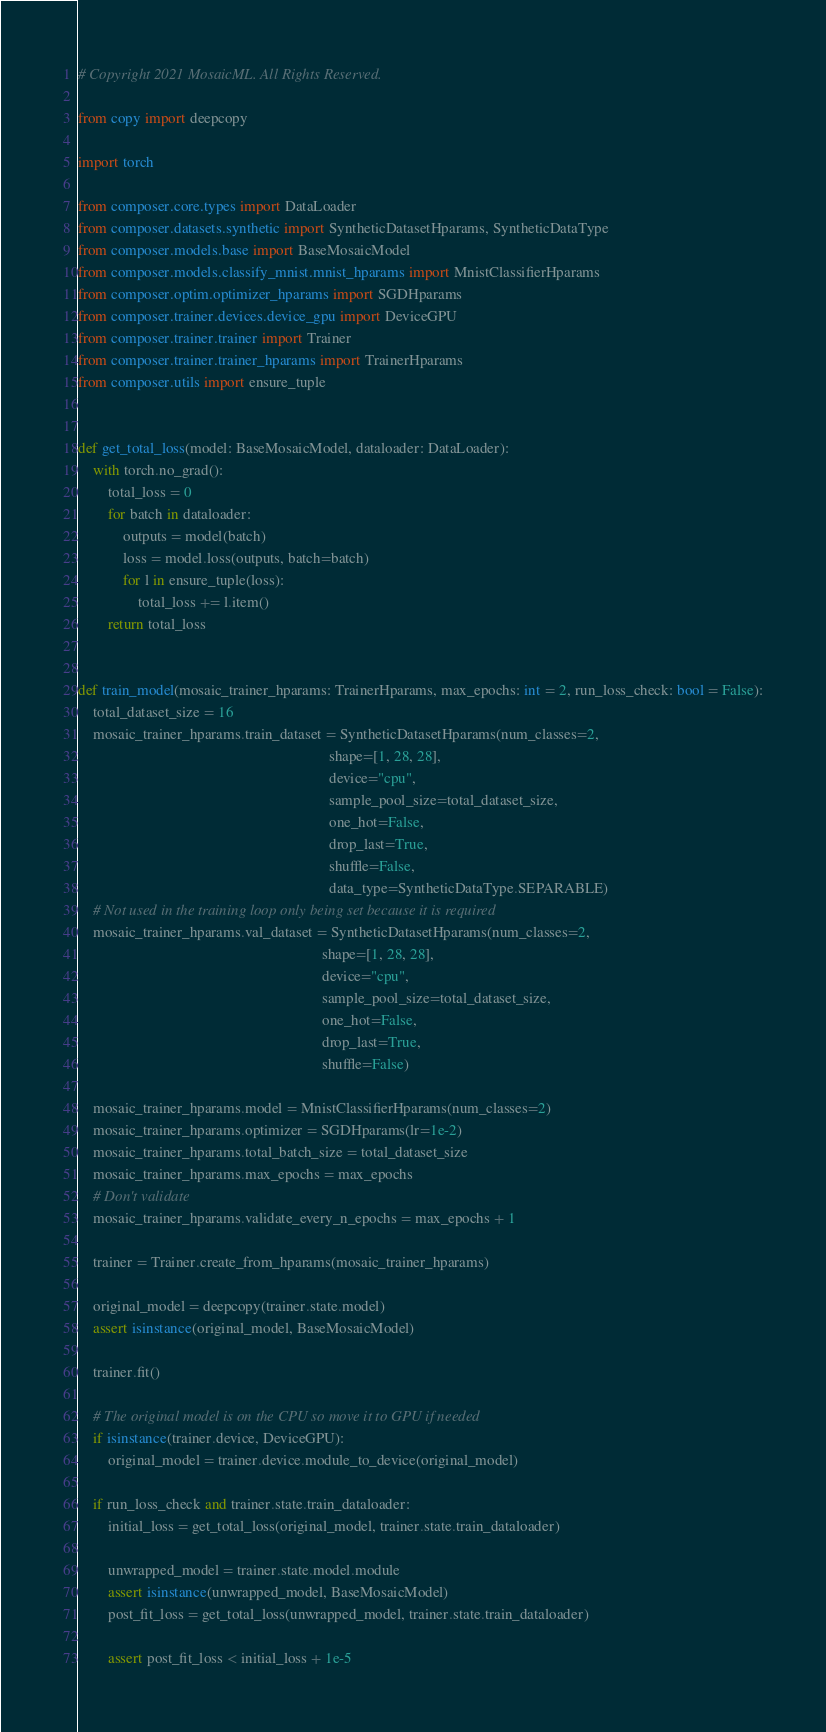<code> <loc_0><loc_0><loc_500><loc_500><_Python_># Copyright 2021 MosaicML. All Rights Reserved.

from copy import deepcopy

import torch

from composer.core.types import DataLoader
from composer.datasets.synthetic import SyntheticDatasetHparams, SyntheticDataType
from composer.models.base import BaseMosaicModel
from composer.models.classify_mnist.mnist_hparams import MnistClassifierHparams
from composer.optim.optimizer_hparams import SGDHparams
from composer.trainer.devices.device_gpu import DeviceGPU
from composer.trainer.trainer import Trainer
from composer.trainer.trainer_hparams import TrainerHparams
from composer.utils import ensure_tuple


def get_total_loss(model: BaseMosaicModel, dataloader: DataLoader):
    with torch.no_grad():
        total_loss = 0
        for batch in dataloader:
            outputs = model(batch)
            loss = model.loss(outputs, batch=batch)
            for l in ensure_tuple(loss):
                total_loss += l.item()
        return total_loss


def train_model(mosaic_trainer_hparams: TrainerHparams, max_epochs: int = 2, run_loss_check: bool = False):
    total_dataset_size = 16
    mosaic_trainer_hparams.train_dataset = SyntheticDatasetHparams(num_classes=2,
                                                                   shape=[1, 28, 28],
                                                                   device="cpu",
                                                                   sample_pool_size=total_dataset_size,
                                                                   one_hot=False,
                                                                   drop_last=True,
                                                                   shuffle=False,
                                                                   data_type=SyntheticDataType.SEPARABLE)
    # Not used in the training loop only being set because it is required
    mosaic_trainer_hparams.val_dataset = SyntheticDatasetHparams(num_classes=2,
                                                                 shape=[1, 28, 28],
                                                                 device="cpu",
                                                                 sample_pool_size=total_dataset_size,
                                                                 one_hot=False,
                                                                 drop_last=True,
                                                                 shuffle=False)

    mosaic_trainer_hparams.model = MnistClassifierHparams(num_classes=2)
    mosaic_trainer_hparams.optimizer = SGDHparams(lr=1e-2)
    mosaic_trainer_hparams.total_batch_size = total_dataset_size
    mosaic_trainer_hparams.max_epochs = max_epochs
    # Don't validate
    mosaic_trainer_hparams.validate_every_n_epochs = max_epochs + 1

    trainer = Trainer.create_from_hparams(mosaic_trainer_hparams)

    original_model = deepcopy(trainer.state.model)
    assert isinstance(original_model, BaseMosaicModel)

    trainer.fit()

    # The original model is on the CPU so move it to GPU if needed
    if isinstance(trainer.device, DeviceGPU):
        original_model = trainer.device.module_to_device(original_model)

    if run_loss_check and trainer.state.train_dataloader:
        initial_loss = get_total_loss(original_model, trainer.state.train_dataloader)

        unwrapped_model = trainer.state.model.module
        assert isinstance(unwrapped_model, BaseMosaicModel)
        post_fit_loss = get_total_loss(unwrapped_model, trainer.state.train_dataloader)

        assert post_fit_loss < initial_loss + 1e-5
</code> 